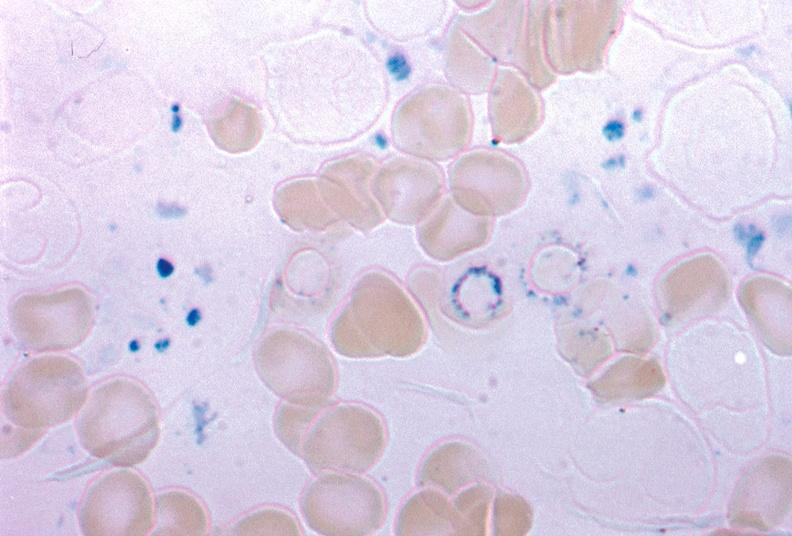what is present?
Answer the question using a single word or phrase. Hematologic 